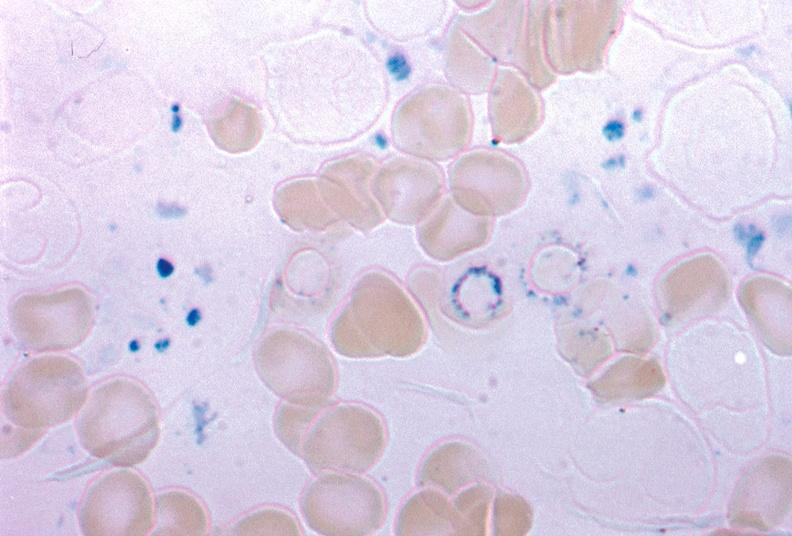what is present?
Answer the question using a single word or phrase. Hematologic 